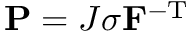<formula> <loc_0><loc_0><loc_500><loc_500>P = J \sigma F ^ { - T }</formula> 